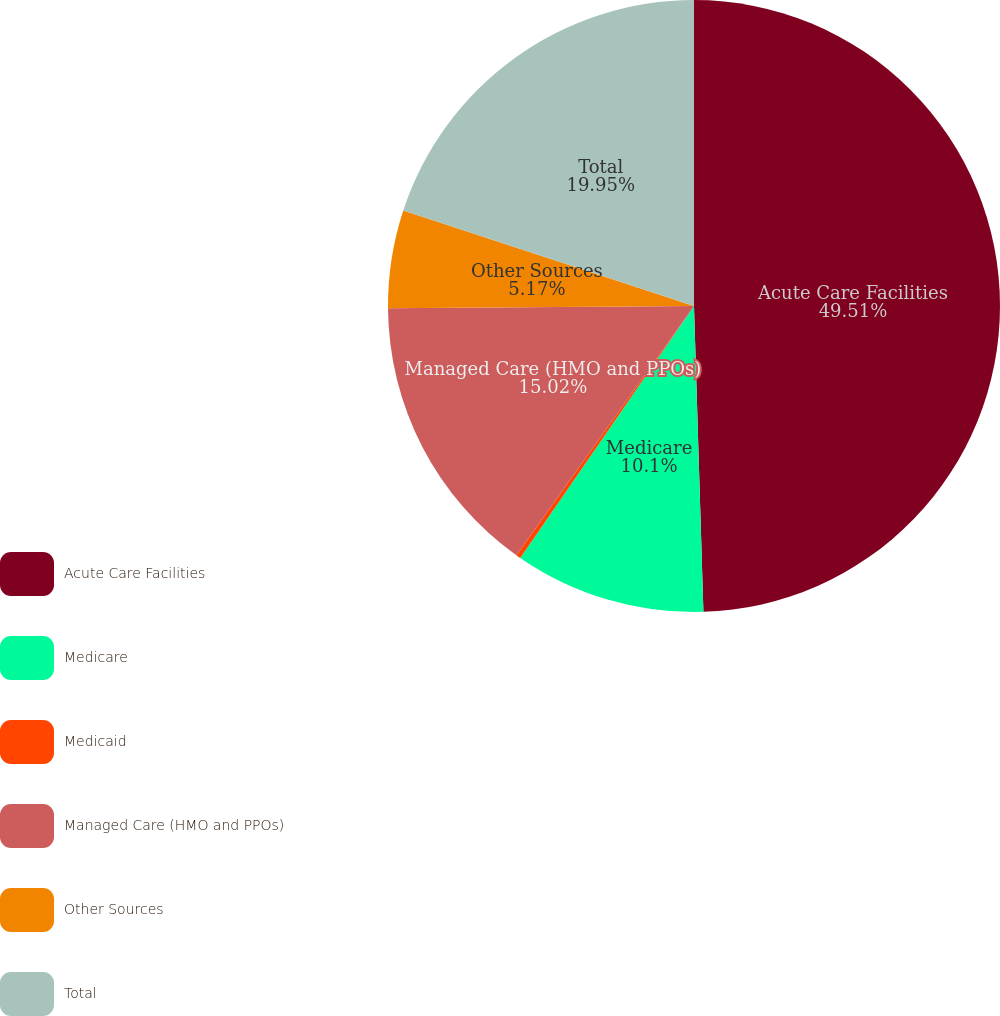Convert chart to OTSL. <chart><loc_0><loc_0><loc_500><loc_500><pie_chart><fcel>Acute Care Facilities<fcel>Medicare<fcel>Medicaid<fcel>Managed Care (HMO and PPOs)<fcel>Other Sources<fcel>Total<nl><fcel>49.51%<fcel>10.1%<fcel>0.25%<fcel>15.02%<fcel>5.17%<fcel>19.95%<nl></chart> 